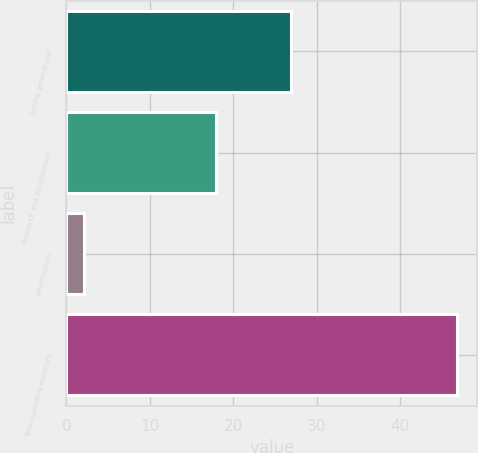Convert chart. <chart><loc_0><loc_0><loc_500><loc_500><bar_chart><fcel>Selling general and<fcel>Research and development<fcel>Amortization<fcel>Total operating expenses<nl><fcel>26.9<fcel>17.9<fcel>2.1<fcel>46.9<nl></chart> 